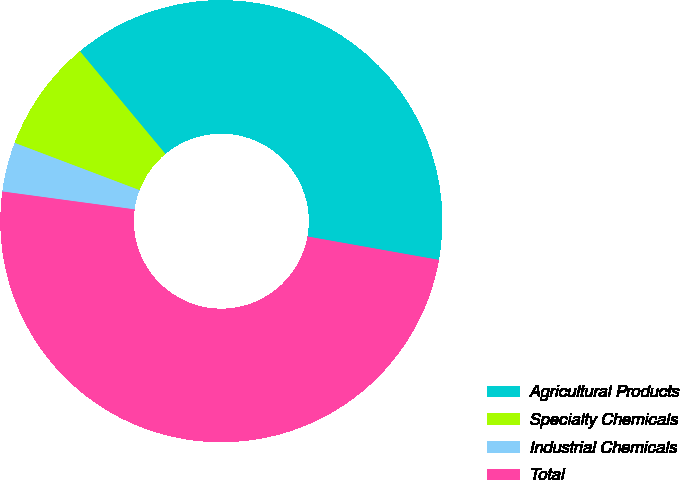Convert chart to OTSL. <chart><loc_0><loc_0><loc_500><loc_500><pie_chart><fcel>Agricultural Products<fcel>Specialty Chemicals<fcel>Industrial Chemicals<fcel>Total<nl><fcel>38.86%<fcel>8.19%<fcel>3.62%<fcel>49.34%<nl></chart> 